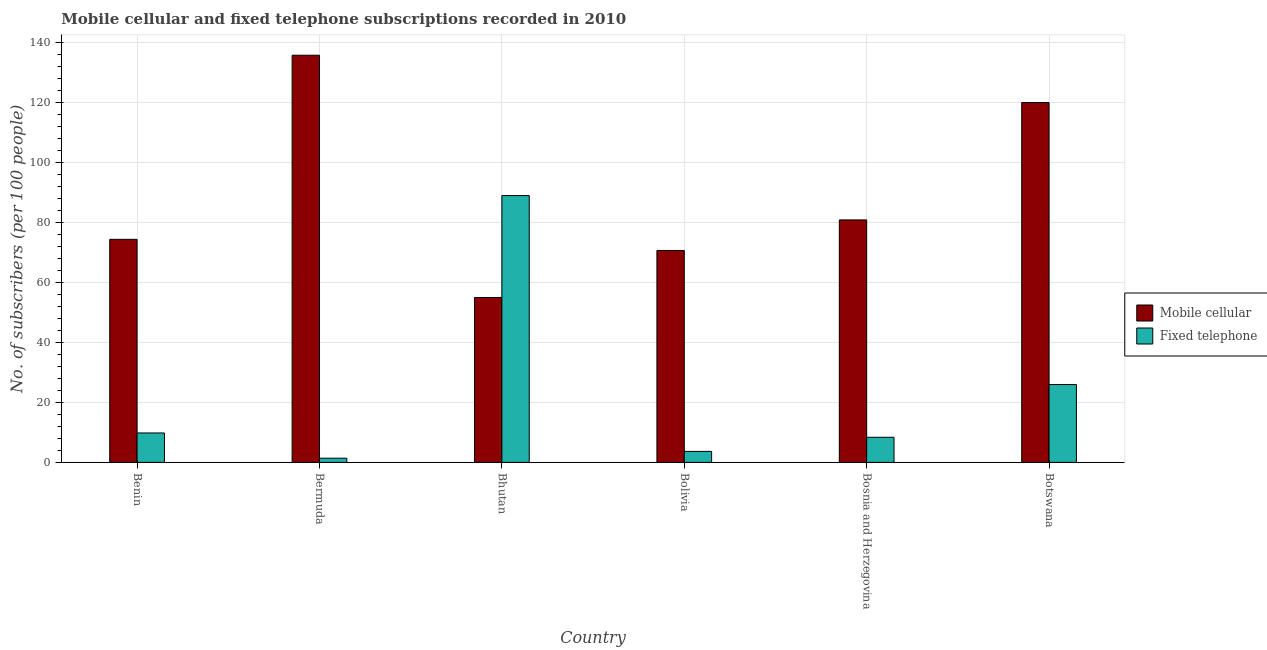How many groups of bars are there?
Your answer should be very brief. 6. Are the number of bars per tick equal to the number of legend labels?
Give a very brief answer. Yes. What is the label of the 3rd group of bars from the left?
Offer a very short reply. Bhutan. In how many cases, is the number of bars for a given country not equal to the number of legend labels?
Provide a succinct answer. 0. What is the number of fixed telephone subscribers in Bhutan?
Make the answer very short. 88.99. Across all countries, what is the maximum number of mobile cellular subscribers?
Provide a short and direct response. 135.79. Across all countries, what is the minimum number of mobile cellular subscribers?
Your response must be concise. 55. In which country was the number of mobile cellular subscribers maximum?
Your answer should be compact. Bermuda. In which country was the number of fixed telephone subscribers minimum?
Provide a succinct answer. Bermuda. What is the total number of mobile cellular subscribers in the graph?
Make the answer very short. 536.76. What is the difference between the number of mobile cellular subscribers in Bermuda and that in Bhutan?
Your answer should be compact. 80.79. What is the difference between the number of fixed telephone subscribers in Bolivia and the number of mobile cellular subscribers in Bhutan?
Your answer should be compact. -51.33. What is the average number of mobile cellular subscribers per country?
Your answer should be compact. 89.46. What is the difference between the number of mobile cellular subscribers and number of fixed telephone subscribers in Benin?
Provide a short and direct response. 64.58. What is the ratio of the number of mobile cellular subscribers in Benin to that in Bermuda?
Your answer should be very brief. 0.55. Is the difference between the number of mobile cellular subscribers in Bosnia and Herzegovina and Botswana greater than the difference between the number of fixed telephone subscribers in Bosnia and Herzegovina and Botswana?
Provide a succinct answer. No. What is the difference between the highest and the second highest number of mobile cellular subscribers?
Provide a succinct answer. 15.78. What is the difference between the highest and the lowest number of mobile cellular subscribers?
Ensure brevity in your answer.  80.79. In how many countries, is the number of fixed telephone subscribers greater than the average number of fixed telephone subscribers taken over all countries?
Keep it short and to the point. 2. Is the sum of the number of fixed telephone subscribers in Bhutan and Botswana greater than the maximum number of mobile cellular subscribers across all countries?
Your answer should be compact. No. What does the 1st bar from the left in Bolivia represents?
Your response must be concise. Mobile cellular. What does the 1st bar from the right in Bosnia and Herzegovina represents?
Your answer should be very brief. Fixed telephone. Are all the bars in the graph horizontal?
Your answer should be compact. No. How many countries are there in the graph?
Give a very brief answer. 6. Are the values on the major ticks of Y-axis written in scientific E-notation?
Your response must be concise. No. How many legend labels are there?
Give a very brief answer. 2. How are the legend labels stacked?
Give a very brief answer. Vertical. What is the title of the graph?
Make the answer very short. Mobile cellular and fixed telephone subscriptions recorded in 2010. Does "Attending school" appear as one of the legend labels in the graph?
Ensure brevity in your answer.  No. What is the label or title of the X-axis?
Offer a very short reply. Country. What is the label or title of the Y-axis?
Give a very brief answer. No. of subscribers (per 100 people). What is the No. of subscribers (per 100 people) in Mobile cellular in Benin?
Ensure brevity in your answer.  74.4. What is the No. of subscribers (per 100 people) in Fixed telephone in Benin?
Provide a short and direct response. 9.81. What is the No. of subscribers (per 100 people) of Mobile cellular in Bermuda?
Offer a very short reply. 135.79. What is the No. of subscribers (per 100 people) of Fixed telephone in Bermuda?
Give a very brief answer. 1.4. What is the No. of subscribers (per 100 people) in Mobile cellular in Bhutan?
Provide a succinct answer. 55. What is the No. of subscribers (per 100 people) of Fixed telephone in Bhutan?
Give a very brief answer. 88.99. What is the No. of subscribers (per 100 people) in Mobile cellular in Bolivia?
Offer a very short reply. 70.69. What is the No. of subscribers (per 100 people) in Fixed telephone in Bolivia?
Your answer should be very brief. 3.67. What is the No. of subscribers (per 100 people) of Mobile cellular in Bosnia and Herzegovina?
Your answer should be compact. 80.87. What is the No. of subscribers (per 100 people) in Fixed telephone in Bosnia and Herzegovina?
Your response must be concise. 8.38. What is the No. of subscribers (per 100 people) in Mobile cellular in Botswana?
Your answer should be very brief. 120.01. What is the No. of subscribers (per 100 people) in Fixed telephone in Botswana?
Your answer should be very brief. 25.97. Across all countries, what is the maximum No. of subscribers (per 100 people) of Mobile cellular?
Offer a terse response. 135.79. Across all countries, what is the maximum No. of subscribers (per 100 people) in Fixed telephone?
Provide a succinct answer. 88.99. Across all countries, what is the minimum No. of subscribers (per 100 people) of Mobile cellular?
Your response must be concise. 55. Across all countries, what is the minimum No. of subscribers (per 100 people) of Fixed telephone?
Keep it short and to the point. 1.4. What is the total No. of subscribers (per 100 people) of Mobile cellular in the graph?
Offer a terse response. 536.76. What is the total No. of subscribers (per 100 people) in Fixed telephone in the graph?
Provide a succinct answer. 138.22. What is the difference between the No. of subscribers (per 100 people) of Mobile cellular in Benin and that in Bermuda?
Keep it short and to the point. -61.4. What is the difference between the No. of subscribers (per 100 people) in Fixed telephone in Benin and that in Bermuda?
Your answer should be compact. 8.41. What is the difference between the No. of subscribers (per 100 people) in Mobile cellular in Benin and that in Bhutan?
Keep it short and to the point. 19.4. What is the difference between the No. of subscribers (per 100 people) in Fixed telephone in Benin and that in Bhutan?
Your answer should be compact. -79.18. What is the difference between the No. of subscribers (per 100 people) in Mobile cellular in Benin and that in Bolivia?
Make the answer very short. 3.71. What is the difference between the No. of subscribers (per 100 people) in Fixed telephone in Benin and that in Bolivia?
Ensure brevity in your answer.  6.15. What is the difference between the No. of subscribers (per 100 people) of Mobile cellular in Benin and that in Bosnia and Herzegovina?
Ensure brevity in your answer.  -6.47. What is the difference between the No. of subscribers (per 100 people) in Fixed telephone in Benin and that in Bosnia and Herzegovina?
Your answer should be compact. 1.43. What is the difference between the No. of subscribers (per 100 people) of Mobile cellular in Benin and that in Botswana?
Your answer should be very brief. -45.61. What is the difference between the No. of subscribers (per 100 people) of Fixed telephone in Benin and that in Botswana?
Make the answer very short. -16.15. What is the difference between the No. of subscribers (per 100 people) in Mobile cellular in Bermuda and that in Bhutan?
Ensure brevity in your answer.  80.79. What is the difference between the No. of subscribers (per 100 people) in Fixed telephone in Bermuda and that in Bhutan?
Keep it short and to the point. -87.59. What is the difference between the No. of subscribers (per 100 people) in Mobile cellular in Bermuda and that in Bolivia?
Make the answer very short. 65.11. What is the difference between the No. of subscribers (per 100 people) in Fixed telephone in Bermuda and that in Bolivia?
Ensure brevity in your answer.  -2.26. What is the difference between the No. of subscribers (per 100 people) of Mobile cellular in Bermuda and that in Bosnia and Herzegovina?
Give a very brief answer. 54.92. What is the difference between the No. of subscribers (per 100 people) of Fixed telephone in Bermuda and that in Bosnia and Herzegovina?
Provide a succinct answer. -6.98. What is the difference between the No. of subscribers (per 100 people) in Mobile cellular in Bermuda and that in Botswana?
Your answer should be very brief. 15.78. What is the difference between the No. of subscribers (per 100 people) of Fixed telephone in Bermuda and that in Botswana?
Offer a terse response. -24.56. What is the difference between the No. of subscribers (per 100 people) of Mobile cellular in Bhutan and that in Bolivia?
Give a very brief answer. -15.69. What is the difference between the No. of subscribers (per 100 people) in Fixed telephone in Bhutan and that in Bolivia?
Provide a short and direct response. 85.32. What is the difference between the No. of subscribers (per 100 people) in Mobile cellular in Bhutan and that in Bosnia and Herzegovina?
Your answer should be very brief. -25.87. What is the difference between the No. of subscribers (per 100 people) of Fixed telephone in Bhutan and that in Bosnia and Herzegovina?
Offer a very short reply. 80.61. What is the difference between the No. of subscribers (per 100 people) in Mobile cellular in Bhutan and that in Botswana?
Offer a very short reply. -65.01. What is the difference between the No. of subscribers (per 100 people) of Fixed telephone in Bhutan and that in Botswana?
Offer a terse response. 63.02. What is the difference between the No. of subscribers (per 100 people) in Mobile cellular in Bolivia and that in Bosnia and Herzegovina?
Give a very brief answer. -10.18. What is the difference between the No. of subscribers (per 100 people) of Fixed telephone in Bolivia and that in Bosnia and Herzegovina?
Make the answer very short. -4.71. What is the difference between the No. of subscribers (per 100 people) of Mobile cellular in Bolivia and that in Botswana?
Your answer should be very brief. -49.32. What is the difference between the No. of subscribers (per 100 people) in Fixed telephone in Bolivia and that in Botswana?
Your answer should be very brief. -22.3. What is the difference between the No. of subscribers (per 100 people) of Mobile cellular in Bosnia and Herzegovina and that in Botswana?
Provide a succinct answer. -39.14. What is the difference between the No. of subscribers (per 100 people) of Fixed telephone in Bosnia and Herzegovina and that in Botswana?
Give a very brief answer. -17.58. What is the difference between the No. of subscribers (per 100 people) of Mobile cellular in Benin and the No. of subscribers (per 100 people) of Fixed telephone in Bermuda?
Offer a very short reply. 72.99. What is the difference between the No. of subscribers (per 100 people) in Mobile cellular in Benin and the No. of subscribers (per 100 people) in Fixed telephone in Bhutan?
Provide a succinct answer. -14.59. What is the difference between the No. of subscribers (per 100 people) in Mobile cellular in Benin and the No. of subscribers (per 100 people) in Fixed telephone in Bolivia?
Offer a terse response. 70.73. What is the difference between the No. of subscribers (per 100 people) in Mobile cellular in Benin and the No. of subscribers (per 100 people) in Fixed telephone in Bosnia and Herzegovina?
Ensure brevity in your answer.  66.02. What is the difference between the No. of subscribers (per 100 people) of Mobile cellular in Benin and the No. of subscribers (per 100 people) of Fixed telephone in Botswana?
Offer a very short reply. 48.43. What is the difference between the No. of subscribers (per 100 people) of Mobile cellular in Bermuda and the No. of subscribers (per 100 people) of Fixed telephone in Bhutan?
Give a very brief answer. 46.8. What is the difference between the No. of subscribers (per 100 people) in Mobile cellular in Bermuda and the No. of subscribers (per 100 people) in Fixed telephone in Bolivia?
Your answer should be very brief. 132.13. What is the difference between the No. of subscribers (per 100 people) of Mobile cellular in Bermuda and the No. of subscribers (per 100 people) of Fixed telephone in Bosnia and Herzegovina?
Offer a terse response. 127.41. What is the difference between the No. of subscribers (per 100 people) in Mobile cellular in Bermuda and the No. of subscribers (per 100 people) in Fixed telephone in Botswana?
Keep it short and to the point. 109.83. What is the difference between the No. of subscribers (per 100 people) of Mobile cellular in Bhutan and the No. of subscribers (per 100 people) of Fixed telephone in Bolivia?
Make the answer very short. 51.33. What is the difference between the No. of subscribers (per 100 people) of Mobile cellular in Bhutan and the No. of subscribers (per 100 people) of Fixed telephone in Bosnia and Herzegovina?
Provide a short and direct response. 46.62. What is the difference between the No. of subscribers (per 100 people) in Mobile cellular in Bhutan and the No. of subscribers (per 100 people) in Fixed telephone in Botswana?
Provide a short and direct response. 29.03. What is the difference between the No. of subscribers (per 100 people) in Mobile cellular in Bolivia and the No. of subscribers (per 100 people) in Fixed telephone in Bosnia and Herzegovina?
Provide a succinct answer. 62.31. What is the difference between the No. of subscribers (per 100 people) of Mobile cellular in Bolivia and the No. of subscribers (per 100 people) of Fixed telephone in Botswana?
Ensure brevity in your answer.  44.72. What is the difference between the No. of subscribers (per 100 people) of Mobile cellular in Bosnia and Herzegovina and the No. of subscribers (per 100 people) of Fixed telephone in Botswana?
Your answer should be compact. 54.91. What is the average No. of subscribers (per 100 people) in Mobile cellular per country?
Make the answer very short. 89.46. What is the average No. of subscribers (per 100 people) in Fixed telephone per country?
Offer a very short reply. 23.04. What is the difference between the No. of subscribers (per 100 people) of Mobile cellular and No. of subscribers (per 100 people) of Fixed telephone in Benin?
Provide a succinct answer. 64.58. What is the difference between the No. of subscribers (per 100 people) in Mobile cellular and No. of subscribers (per 100 people) in Fixed telephone in Bermuda?
Give a very brief answer. 134.39. What is the difference between the No. of subscribers (per 100 people) of Mobile cellular and No. of subscribers (per 100 people) of Fixed telephone in Bhutan?
Provide a short and direct response. -33.99. What is the difference between the No. of subscribers (per 100 people) in Mobile cellular and No. of subscribers (per 100 people) in Fixed telephone in Bolivia?
Your answer should be compact. 67.02. What is the difference between the No. of subscribers (per 100 people) in Mobile cellular and No. of subscribers (per 100 people) in Fixed telephone in Bosnia and Herzegovina?
Your response must be concise. 72.49. What is the difference between the No. of subscribers (per 100 people) in Mobile cellular and No. of subscribers (per 100 people) in Fixed telephone in Botswana?
Your answer should be very brief. 94.04. What is the ratio of the No. of subscribers (per 100 people) of Mobile cellular in Benin to that in Bermuda?
Ensure brevity in your answer.  0.55. What is the ratio of the No. of subscribers (per 100 people) of Fixed telephone in Benin to that in Bermuda?
Offer a very short reply. 7. What is the ratio of the No. of subscribers (per 100 people) in Mobile cellular in Benin to that in Bhutan?
Provide a short and direct response. 1.35. What is the ratio of the No. of subscribers (per 100 people) of Fixed telephone in Benin to that in Bhutan?
Your answer should be very brief. 0.11. What is the ratio of the No. of subscribers (per 100 people) in Mobile cellular in Benin to that in Bolivia?
Provide a succinct answer. 1.05. What is the ratio of the No. of subscribers (per 100 people) of Fixed telephone in Benin to that in Bolivia?
Ensure brevity in your answer.  2.68. What is the ratio of the No. of subscribers (per 100 people) in Mobile cellular in Benin to that in Bosnia and Herzegovina?
Your answer should be compact. 0.92. What is the ratio of the No. of subscribers (per 100 people) in Fixed telephone in Benin to that in Bosnia and Herzegovina?
Your answer should be compact. 1.17. What is the ratio of the No. of subscribers (per 100 people) in Mobile cellular in Benin to that in Botswana?
Give a very brief answer. 0.62. What is the ratio of the No. of subscribers (per 100 people) in Fixed telephone in Benin to that in Botswana?
Offer a terse response. 0.38. What is the ratio of the No. of subscribers (per 100 people) of Mobile cellular in Bermuda to that in Bhutan?
Make the answer very short. 2.47. What is the ratio of the No. of subscribers (per 100 people) in Fixed telephone in Bermuda to that in Bhutan?
Give a very brief answer. 0.02. What is the ratio of the No. of subscribers (per 100 people) of Mobile cellular in Bermuda to that in Bolivia?
Make the answer very short. 1.92. What is the ratio of the No. of subscribers (per 100 people) in Fixed telephone in Bermuda to that in Bolivia?
Ensure brevity in your answer.  0.38. What is the ratio of the No. of subscribers (per 100 people) in Mobile cellular in Bermuda to that in Bosnia and Herzegovina?
Make the answer very short. 1.68. What is the ratio of the No. of subscribers (per 100 people) of Fixed telephone in Bermuda to that in Bosnia and Herzegovina?
Give a very brief answer. 0.17. What is the ratio of the No. of subscribers (per 100 people) of Mobile cellular in Bermuda to that in Botswana?
Your response must be concise. 1.13. What is the ratio of the No. of subscribers (per 100 people) of Fixed telephone in Bermuda to that in Botswana?
Offer a terse response. 0.05. What is the ratio of the No. of subscribers (per 100 people) of Mobile cellular in Bhutan to that in Bolivia?
Make the answer very short. 0.78. What is the ratio of the No. of subscribers (per 100 people) in Fixed telephone in Bhutan to that in Bolivia?
Your answer should be very brief. 24.27. What is the ratio of the No. of subscribers (per 100 people) of Mobile cellular in Bhutan to that in Bosnia and Herzegovina?
Provide a short and direct response. 0.68. What is the ratio of the No. of subscribers (per 100 people) in Fixed telephone in Bhutan to that in Bosnia and Herzegovina?
Your answer should be compact. 10.62. What is the ratio of the No. of subscribers (per 100 people) in Mobile cellular in Bhutan to that in Botswana?
Your answer should be very brief. 0.46. What is the ratio of the No. of subscribers (per 100 people) in Fixed telephone in Bhutan to that in Botswana?
Offer a terse response. 3.43. What is the ratio of the No. of subscribers (per 100 people) in Mobile cellular in Bolivia to that in Bosnia and Herzegovina?
Ensure brevity in your answer.  0.87. What is the ratio of the No. of subscribers (per 100 people) of Fixed telephone in Bolivia to that in Bosnia and Herzegovina?
Give a very brief answer. 0.44. What is the ratio of the No. of subscribers (per 100 people) in Mobile cellular in Bolivia to that in Botswana?
Your response must be concise. 0.59. What is the ratio of the No. of subscribers (per 100 people) in Fixed telephone in Bolivia to that in Botswana?
Ensure brevity in your answer.  0.14. What is the ratio of the No. of subscribers (per 100 people) of Mobile cellular in Bosnia and Herzegovina to that in Botswana?
Make the answer very short. 0.67. What is the ratio of the No. of subscribers (per 100 people) in Fixed telephone in Bosnia and Herzegovina to that in Botswana?
Offer a terse response. 0.32. What is the difference between the highest and the second highest No. of subscribers (per 100 people) of Mobile cellular?
Keep it short and to the point. 15.78. What is the difference between the highest and the second highest No. of subscribers (per 100 people) in Fixed telephone?
Provide a short and direct response. 63.02. What is the difference between the highest and the lowest No. of subscribers (per 100 people) in Mobile cellular?
Provide a short and direct response. 80.79. What is the difference between the highest and the lowest No. of subscribers (per 100 people) of Fixed telephone?
Your response must be concise. 87.59. 